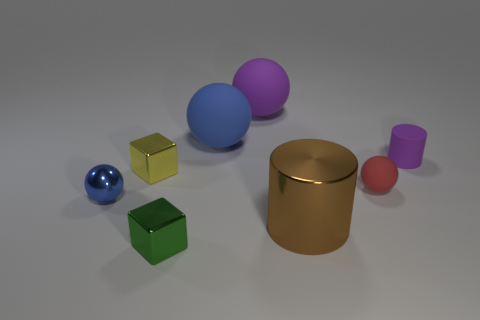Which object in the image is the largest? The largest object appears to be the gold cylindrical object in the center of the image, which has the greatest volume compared to the other items depicted. What could this imply about its weight? If all objects are made of the same material, the gold cylinder would likely be the heaviest due to its larger volume. However, without knowing the material density, we can't say for sure. 